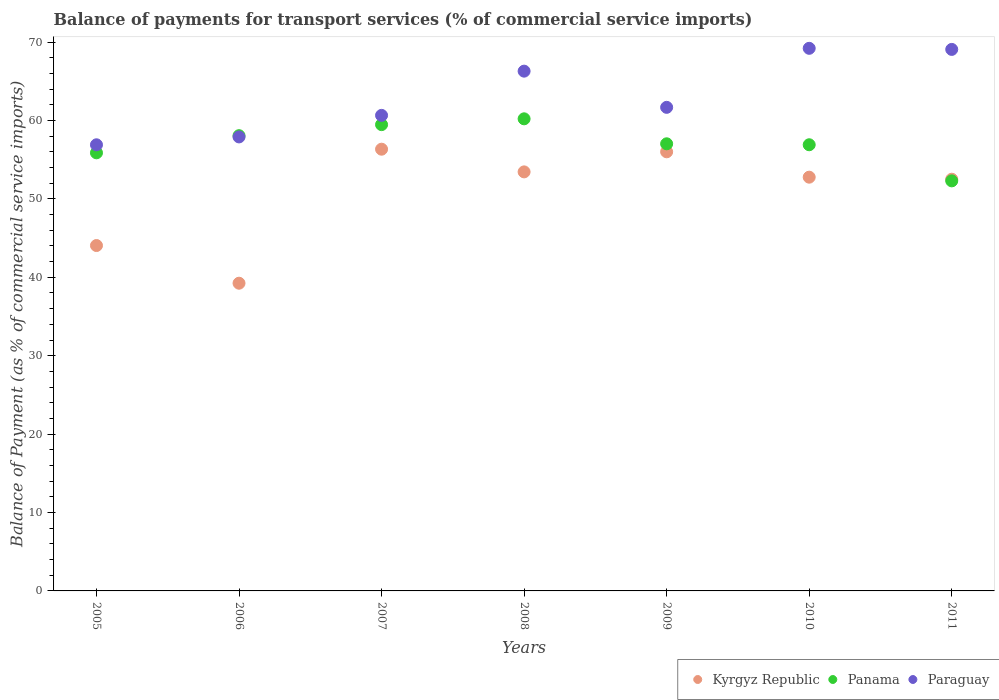Is the number of dotlines equal to the number of legend labels?
Provide a succinct answer. Yes. What is the balance of payments for transport services in Kyrgyz Republic in 2010?
Give a very brief answer. 52.77. Across all years, what is the maximum balance of payments for transport services in Panama?
Provide a succinct answer. 60.21. Across all years, what is the minimum balance of payments for transport services in Kyrgyz Republic?
Offer a very short reply. 39.24. In which year was the balance of payments for transport services in Panama minimum?
Offer a very short reply. 2011. What is the total balance of payments for transport services in Panama in the graph?
Make the answer very short. 399.83. What is the difference between the balance of payments for transport services in Kyrgyz Republic in 2007 and that in 2009?
Keep it short and to the point. 0.33. What is the difference between the balance of payments for transport services in Kyrgyz Republic in 2006 and the balance of payments for transport services in Paraguay in 2007?
Offer a very short reply. -21.4. What is the average balance of payments for transport services in Panama per year?
Provide a short and direct response. 57.12. In the year 2008, what is the difference between the balance of payments for transport services in Panama and balance of payments for transport services in Kyrgyz Republic?
Ensure brevity in your answer.  6.77. What is the ratio of the balance of payments for transport services in Paraguay in 2005 to that in 2008?
Keep it short and to the point. 0.86. Is the balance of payments for transport services in Paraguay in 2009 less than that in 2010?
Ensure brevity in your answer.  Yes. What is the difference between the highest and the second highest balance of payments for transport services in Kyrgyz Republic?
Offer a very short reply. 0.33. What is the difference between the highest and the lowest balance of payments for transport services in Panama?
Provide a succinct answer. 7.91. Does the balance of payments for transport services in Paraguay monotonically increase over the years?
Your answer should be very brief. No. Is the balance of payments for transport services in Kyrgyz Republic strictly greater than the balance of payments for transport services in Paraguay over the years?
Ensure brevity in your answer.  No. What is the difference between two consecutive major ticks on the Y-axis?
Offer a terse response. 10. Does the graph contain grids?
Your response must be concise. No. Where does the legend appear in the graph?
Provide a short and direct response. Bottom right. What is the title of the graph?
Your response must be concise. Balance of payments for transport services (% of commercial service imports). What is the label or title of the X-axis?
Keep it short and to the point. Years. What is the label or title of the Y-axis?
Provide a short and direct response. Balance of Payment (as % of commercial service imports). What is the Balance of Payment (as % of commercial service imports) of Kyrgyz Republic in 2005?
Your response must be concise. 44.05. What is the Balance of Payment (as % of commercial service imports) of Panama in 2005?
Offer a very short reply. 55.87. What is the Balance of Payment (as % of commercial service imports) of Paraguay in 2005?
Provide a succinct answer. 56.9. What is the Balance of Payment (as % of commercial service imports) in Kyrgyz Republic in 2006?
Provide a succinct answer. 39.24. What is the Balance of Payment (as % of commercial service imports) of Panama in 2006?
Offer a terse response. 58.06. What is the Balance of Payment (as % of commercial service imports) in Paraguay in 2006?
Make the answer very short. 57.9. What is the Balance of Payment (as % of commercial service imports) of Kyrgyz Republic in 2007?
Make the answer very short. 56.33. What is the Balance of Payment (as % of commercial service imports) of Panama in 2007?
Make the answer very short. 59.47. What is the Balance of Payment (as % of commercial service imports) of Paraguay in 2007?
Give a very brief answer. 60.65. What is the Balance of Payment (as % of commercial service imports) of Kyrgyz Republic in 2008?
Offer a terse response. 53.44. What is the Balance of Payment (as % of commercial service imports) in Panama in 2008?
Give a very brief answer. 60.21. What is the Balance of Payment (as % of commercial service imports) in Paraguay in 2008?
Provide a short and direct response. 66.29. What is the Balance of Payment (as % of commercial service imports) of Kyrgyz Republic in 2009?
Your answer should be very brief. 56. What is the Balance of Payment (as % of commercial service imports) of Panama in 2009?
Give a very brief answer. 57.02. What is the Balance of Payment (as % of commercial service imports) of Paraguay in 2009?
Offer a terse response. 61.67. What is the Balance of Payment (as % of commercial service imports) of Kyrgyz Republic in 2010?
Provide a succinct answer. 52.77. What is the Balance of Payment (as % of commercial service imports) of Panama in 2010?
Provide a succinct answer. 56.9. What is the Balance of Payment (as % of commercial service imports) in Paraguay in 2010?
Your answer should be compact. 69.2. What is the Balance of Payment (as % of commercial service imports) in Kyrgyz Republic in 2011?
Give a very brief answer. 52.51. What is the Balance of Payment (as % of commercial service imports) of Panama in 2011?
Provide a succinct answer. 52.3. What is the Balance of Payment (as % of commercial service imports) of Paraguay in 2011?
Provide a short and direct response. 69.06. Across all years, what is the maximum Balance of Payment (as % of commercial service imports) in Kyrgyz Republic?
Make the answer very short. 56.33. Across all years, what is the maximum Balance of Payment (as % of commercial service imports) in Panama?
Provide a succinct answer. 60.21. Across all years, what is the maximum Balance of Payment (as % of commercial service imports) in Paraguay?
Give a very brief answer. 69.2. Across all years, what is the minimum Balance of Payment (as % of commercial service imports) in Kyrgyz Republic?
Your answer should be compact. 39.24. Across all years, what is the minimum Balance of Payment (as % of commercial service imports) of Panama?
Provide a short and direct response. 52.3. Across all years, what is the minimum Balance of Payment (as % of commercial service imports) in Paraguay?
Ensure brevity in your answer.  56.9. What is the total Balance of Payment (as % of commercial service imports) of Kyrgyz Republic in the graph?
Ensure brevity in your answer.  354.34. What is the total Balance of Payment (as % of commercial service imports) of Panama in the graph?
Make the answer very short. 399.83. What is the total Balance of Payment (as % of commercial service imports) of Paraguay in the graph?
Offer a terse response. 441.67. What is the difference between the Balance of Payment (as % of commercial service imports) of Kyrgyz Republic in 2005 and that in 2006?
Offer a very short reply. 4.81. What is the difference between the Balance of Payment (as % of commercial service imports) in Panama in 2005 and that in 2006?
Give a very brief answer. -2.19. What is the difference between the Balance of Payment (as % of commercial service imports) of Paraguay in 2005 and that in 2006?
Your answer should be very brief. -1. What is the difference between the Balance of Payment (as % of commercial service imports) of Kyrgyz Republic in 2005 and that in 2007?
Give a very brief answer. -12.29. What is the difference between the Balance of Payment (as % of commercial service imports) of Panama in 2005 and that in 2007?
Ensure brevity in your answer.  -3.59. What is the difference between the Balance of Payment (as % of commercial service imports) of Paraguay in 2005 and that in 2007?
Provide a succinct answer. -3.75. What is the difference between the Balance of Payment (as % of commercial service imports) in Kyrgyz Republic in 2005 and that in 2008?
Provide a short and direct response. -9.39. What is the difference between the Balance of Payment (as % of commercial service imports) in Panama in 2005 and that in 2008?
Give a very brief answer. -4.34. What is the difference between the Balance of Payment (as % of commercial service imports) in Paraguay in 2005 and that in 2008?
Your answer should be very brief. -9.39. What is the difference between the Balance of Payment (as % of commercial service imports) in Kyrgyz Republic in 2005 and that in 2009?
Offer a terse response. -11.95. What is the difference between the Balance of Payment (as % of commercial service imports) in Panama in 2005 and that in 2009?
Keep it short and to the point. -1.15. What is the difference between the Balance of Payment (as % of commercial service imports) in Paraguay in 2005 and that in 2009?
Give a very brief answer. -4.78. What is the difference between the Balance of Payment (as % of commercial service imports) in Kyrgyz Republic in 2005 and that in 2010?
Your answer should be very brief. -8.72. What is the difference between the Balance of Payment (as % of commercial service imports) of Panama in 2005 and that in 2010?
Offer a very short reply. -1.03. What is the difference between the Balance of Payment (as % of commercial service imports) in Paraguay in 2005 and that in 2010?
Make the answer very short. -12.3. What is the difference between the Balance of Payment (as % of commercial service imports) in Kyrgyz Republic in 2005 and that in 2011?
Offer a terse response. -8.46. What is the difference between the Balance of Payment (as % of commercial service imports) in Panama in 2005 and that in 2011?
Make the answer very short. 3.58. What is the difference between the Balance of Payment (as % of commercial service imports) of Paraguay in 2005 and that in 2011?
Your answer should be very brief. -12.16. What is the difference between the Balance of Payment (as % of commercial service imports) in Kyrgyz Republic in 2006 and that in 2007?
Make the answer very short. -17.09. What is the difference between the Balance of Payment (as % of commercial service imports) in Panama in 2006 and that in 2007?
Your answer should be very brief. -1.41. What is the difference between the Balance of Payment (as % of commercial service imports) of Paraguay in 2006 and that in 2007?
Give a very brief answer. -2.75. What is the difference between the Balance of Payment (as % of commercial service imports) in Kyrgyz Republic in 2006 and that in 2008?
Your answer should be very brief. -14.2. What is the difference between the Balance of Payment (as % of commercial service imports) of Panama in 2006 and that in 2008?
Your answer should be very brief. -2.15. What is the difference between the Balance of Payment (as % of commercial service imports) of Paraguay in 2006 and that in 2008?
Keep it short and to the point. -8.39. What is the difference between the Balance of Payment (as % of commercial service imports) in Kyrgyz Republic in 2006 and that in 2009?
Your response must be concise. -16.76. What is the difference between the Balance of Payment (as % of commercial service imports) in Panama in 2006 and that in 2009?
Provide a short and direct response. 1.04. What is the difference between the Balance of Payment (as % of commercial service imports) of Paraguay in 2006 and that in 2009?
Provide a short and direct response. -3.77. What is the difference between the Balance of Payment (as % of commercial service imports) of Kyrgyz Republic in 2006 and that in 2010?
Ensure brevity in your answer.  -13.52. What is the difference between the Balance of Payment (as % of commercial service imports) of Panama in 2006 and that in 2010?
Provide a short and direct response. 1.16. What is the difference between the Balance of Payment (as % of commercial service imports) of Paraguay in 2006 and that in 2010?
Provide a succinct answer. -11.3. What is the difference between the Balance of Payment (as % of commercial service imports) in Kyrgyz Republic in 2006 and that in 2011?
Your response must be concise. -13.26. What is the difference between the Balance of Payment (as % of commercial service imports) in Panama in 2006 and that in 2011?
Offer a very short reply. 5.76. What is the difference between the Balance of Payment (as % of commercial service imports) in Paraguay in 2006 and that in 2011?
Ensure brevity in your answer.  -11.16. What is the difference between the Balance of Payment (as % of commercial service imports) of Kyrgyz Republic in 2007 and that in 2008?
Offer a terse response. 2.89. What is the difference between the Balance of Payment (as % of commercial service imports) of Panama in 2007 and that in 2008?
Provide a succinct answer. -0.74. What is the difference between the Balance of Payment (as % of commercial service imports) of Paraguay in 2007 and that in 2008?
Offer a terse response. -5.64. What is the difference between the Balance of Payment (as % of commercial service imports) in Kyrgyz Republic in 2007 and that in 2009?
Give a very brief answer. 0.33. What is the difference between the Balance of Payment (as % of commercial service imports) of Panama in 2007 and that in 2009?
Give a very brief answer. 2.44. What is the difference between the Balance of Payment (as % of commercial service imports) of Paraguay in 2007 and that in 2009?
Your answer should be very brief. -1.02. What is the difference between the Balance of Payment (as % of commercial service imports) of Kyrgyz Republic in 2007 and that in 2010?
Make the answer very short. 3.57. What is the difference between the Balance of Payment (as % of commercial service imports) in Panama in 2007 and that in 2010?
Provide a short and direct response. 2.57. What is the difference between the Balance of Payment (as % of commercial service imports) in Paraguay in 2007 and that in 2010?
Offer a very short reply. -8.55. What is the difference between the Balance of Payment (as % of commercial service imports) in Kyrgyz Republic in 2007 and that in 2011?
Offer a very short reply. 3.83. What is the difference between the Balance of Payment (as % of commercial service imports) of Panama in 2007 and that in 2011?
Your answer should be compact. 7.17. What is the difference between the Balance of Payment (as % of commercial service imports) of Paraguay in 2007 and that in 2011?
Make the answer very short. -8.41. What is the difference between the Balance of Payment (as % of commercial service imports) in Kyrgyz Republic in 2008 and that in 2009?
Ensure brevity in your answer.  -2.56. What is the difference between the Balance of Payment (as % of commercial service imports) of Panama in 2008 and that in 2009?
Your answer should be very brief. 3.19. What is the difference between the Balance of Payment (as % of commercial service imports) of Paraguay in 2008 and that in 2009?
Your response must be concise. 4.62. What is the difference between the Balance of Payment (as % of commercial service imports) of Kyrgyz Republic in 2008 and that in 2010?
Give a very brief answer. 0.68. What is the difference between the Balance of Payment (as % of commercial service imports) of Panama in 2008 and that in 2010?
Your answer should be compact. 3.31. What is the difference between the Balance of Payment (as % of commercial service imports) in Paraguay in 2008 and that in 2010?
Provide a succinct answer. -2.91. What is the difference between the Balance of Payment (as % of commercial service imports) of Kyrgyz Republic in 2008 and that in 2011?
Keep it short and to the point. 0.94. What is the difference between the Balance of Payment (as % of commercial service imports) of Panama in 2008 and that in 2011?
Ensure brevity in your answer.  7.91. What is the difference between the Balance of Payment (as % of commercial service imports) of Paraguay in 2008 and that in 2011?
Your response must be concise. -2.77. What is the difference between the Balance of Payment (as % of commercial service imports) in Kyrgyz Republic in 2009 and that in 2010?
Your answer should be compact. 3.24. What is the difference between the Balance of Payment (as % of commercial service imports) in Panama in 2009 and that in 2010?
Your response must be concise. 0.12. What is the difference between the Balance of Payment (as % of commercial service imports) in Paraguay in 2009 and that in 2010?
Make the answer very short. -7.53. What is the difference between the Balance of Payment (as % of commercial service imports) of Kyrgyz Republic in 2009 and that in 2011?
Provide a short and direct response. 3.5. What is the difference between the Balance of Payment (as % of commercial service imports) of Panama in 2009 and that in 2011?
Give a very brief answer. 4.73. What is the difference between the Balance of Payment (as % of commercial service imports) in Paraguay in 2009 and that in 2011?
Provide a succinct answer. -7.39. What is the difference between the Balance of Payment (as % of commercial service imports) of Kyrgyz Republic in 2010 and that in 2011?
Offer a very short reply. 0.26. What is the difference between the Balance of Payment (as % of commercial service imports) of Panama in 2010 and that in 2011?
Offer a terse response. 4.61. What is the difference between the Balance of Payment (as % of commercial service imports) of Paraguay in 2010 and that in 2011?
Ensure brevity in your answer.  0.14. What is the difference between the Balance of Payment (as % of commercial service imports) of Kyrgyz Republic in 2005 and the Balance of Payment (as % of commercial service imports) of Panama in 2006?
Your answer should be very brief. -14.01. What is the difference between the Balance of Payment (as % of commercial service imports) in Kyrgyz Republic in 2005 and the Balance of Payment (as % of commercial service imports) in Paraguay in 2006?
Ensure brevity in your answer.  -13.85. What is the difference between the Balance of Payment (as % of commercial service imports) in Panama in 2005 and the Balance of Payment (as % of commercial service imports) in Paraguay in 2006?
Provide a succinct answer. -2.03. What is the difference between the Balance of Payment (as % of commercial service imports) in Kyrgyz Republic in 2005 and the Balance of Payment (as % of commercial service imports) in Panama in 2007?
Provide a succinct answer. -15.42. What is the difference between the Balance of Payment (as % of commercial service imports) in Kyrgyz Republic in 2005 and the Balance of Payment (as % of commercial service imports) in Paraguay in 2007?
Keep it short and to the point. -16.6. What is the difference between the Balance of Payment (as % of commercial service imports) of Panama in 2005 and the Balance of Payment (as % of commercial service imports) of Paraguay in 2007?
Ensure brevity in your answer.  -4.78. What is the difference between the Balance of Payment (as % of commercial service imports) in Kyrgyz Republic in 2005 and the Balance of Payment (as % of commercial service imports) in Panama in 2008?
Give a very brief answer. -16.16. What is the difference between the Balance of Payment (as % of commercial service imports) of Kyrgyz Republic in 2005 and the Balance of Payment (as % of commercial service imports) of Paraguay in 2008?
Your answer should be compact. -22.24. What is the difference between the Balance of Payment (as % of commercial service imports) of Panama in 2005 and the Balance of Payment (as % of commercial service imports) of Paraguay in 2008?
Offer a very short reply. -10.42. What is the difference between the Balance of Payment (as % of commercial service imports) of Kyrgyz Republic in 2005 and the Balance of Payment (as % of commercial service imports) of Panama in 2009?
Keep it short and to the point. -12.97. What is the difference between the Balance of Payment (as % of commercial service imports) in Kyrgyz Republic in 2005 and the Balance of Payment (as % of commercial service imports) in Paraguay in 2009?
Offer a very short reply. -17.62. What is the difference between the Balance of Payment (as % of commercial service imports) of Panama in 2005 and the Balance of Payment (as % of commercial service imports) of Paraguay in 2009?
Provide a short and direct response. -5.8. What is the difference between the Balance of Payment (as % of commercial service imports) of Kyrgyz Republic in 2005 and the Balance of Payment (as % of commercial service imports) of Panama in 2010?
Give a very brief answer. -12.85. What is the difference between the Balance of Payment (as % of commercial service imports) in Kyrgyz Republic in 2005 and the Balance of Payment (as % of commercial service imports) in Paraguay in 2010?
Offer a terse response. -25.15. What is the difference between the Balance of Payment (as % of commercial service imports) of Panama in 2005 and the Balance of Payment (as % of commercial service imports) of Paraguay in 2010?
Offer a terse response. -13.33. What is the difference between the Balance of Payment (as % of commercial service imports) in Kyrgyz Republic in 2005 and the Balance of Payment (as % of commercial service imports) in Panama in 2011?
Your response must be concise. -8.25. What is the difference between the Balance of Payment (as % of commercial service imports) of Kyrgyz Republic in 2005 and the Balance of Payment (as % of commercial service imports) of Paraguay in 2011?
Ensure brevity in your answer.  -25.01. What is the difference between the Balance of Payment (as % of commercial service imports) in Panama in 2005 and the Balance of Payment (as % of commercial service imports) in Paraguay in 2011?
Ensure brevity in your answer.  -13.19. What is the difference between the Balance of Payment (as % of commercial service imports) in Kyrgyz Republic in 2006 and the Balance of Payment (as % of commercial service imports) in Panama in 2007?
Provide a short and direct response. -20.22. What is the difference between the Balance of Payment (as % of commercial service imports) in Kyrgyz Republic in 2006 and the Balance of Payment (as % of commercial service imports) in Paraguay in 2007?
Offer a very short reply. -21.4. What is the difference between the Balance of Payment (as % of commercial service imports) in Panama in 2006 and the Balance of Payment (as % of commercial service imports) in Paraguay in 2007?
Keep it short and to the point. -2.59. What is the difference between the Balance of Payment (as % of commercial service imports) of Kyrgyz Republic in 2006 and the Balance of Payment (as % of commercial service imports) of Panama in 2008?
Your response must be concise. -20.97. What is the difference between the Balance of Payment (as % of commercial service imports) in Kyrgyz Republic in 2006 and the Balance of Payment (as % of commercial service imports) in Paraguay in 2008?
Provide a succinct answer. -27.05. What is the difference between the Balance of Payment (as % of commercial service imports) in Panama in 2006 and the Balance of Payment (as % of commercial service imports) in Paraguay in 2008?
Keep it short and to the point. -8.23. What is the difference between the Balance of Payment (as % of commercial service imports) of Kyrgyz Republic in 2006 and the Balance of Payment (as % of commercial service imports) of Panama in 2009?
Give a very brief answer. -17.78. What is the difference between the Balance of Payment (as % of commercial service imports) of Kyrgyz Republic in 2006 and the Balance of Payment (as % of commercial service imports) of Paraguay in 2009?
Keep it short and to the point. -22.43. What is the difference between the Balance of Payment (as % of commercial service imports) of Panama in 2006 and the Balance of Payment (as % of commercial service imports) of Paraguay in 2009?
Offer a terse response. -3.61. What is the difference between the Balance of Payment (as % of commercial service imports) in Kyrgyz Republic in 2006 and the Balance of Payment (as % of commercial service imports) in Panama in 2010?
Provide a short and direct response. -17.66. What is the difference between the Balance of Payment (as % of commercial service imports) of Kyrgyz Republic in 2006 and the Balance of Payment (as % of commercial service imports) of Paraguay in 2010?
Your response must be concise. -29.96. What is the difference between the Balance of Payment (as % of commercial service imports) of Panama in 2006 and the Balance of Payment (as % of commercial service imports) of Paraguay in 2010?
Provide a short and direct response. -11.14. What is the difference between the Balance of Payment (as % of commercial service imports) in Kyrgyz Republic in 2006 and the Balance of Payment (as % of commercial service imports) in Panama in 2011?
Offer a terse response. -13.05. What is the difference between the Balance of Payment (as % of commercial service imports) of Kyrgyz Republic in 2006 and the Balance of Payment (as % of commercial service imports) of Paraguay in 2011?
Provide a succinct answer. -29.82. What is the difference between the Balance of Payment (as % of commercial service imports) in Panama in 2006 and the Balance of Payment (as % of commercial service imports) in Paraguay in 2011?
Offer a terse response. -11. What is the difference between the Balance of Payment (as % of commercial service imports) of Kyrgyz Republic in 2007 and the Balance of Payment (as % of commercial service imports) of Panama in 2008?
Your answer should be very brief. -3.87. What is the difference between the Balance of Payment (as % of commercial service imports) of Kyrgyz Republic in 2007 and the Balance of Payment (as % of commercial service imports) of Paraguay in 2008?
Provide a succinct answer. -9.95. What is the difference between the Balance of Payment (as % of commercial service imports) in Panama in 2007 and the Balance of Payment (as % of commercial service imports) in Paraguay in 2008?
Provide a short and direct response. -6.82. What is the difference between the Balance of Payment (as % of commercial service imports) in Kyrgyz Republic in 2007 and the Balance of Payment (as % of commercial service imports) in Panama in 2009?
Offer a terse response. -0.69. What is the difference between the Balance of Payment (as % of commercial service imports) in Kyrgyz Republic in 2007 and the Balance of Payment (as % of commercial service imports) in Paraguay in 2009?
Your answer should be compact. -5.34. What is the difference between the Balance of Payment (as % of commercial service imports) in Panama in 2007 and the Balance of Payment (as % of commercial service imports) in Paraguay in 2009?
Provide a short and direct response. -2.21. What is the difference between the Balance of Payment (as % of commercial service imports) of Kyrgyz Republic in 2007 and the Balance of Payment (as % of commercial service imports) of Panama in 2010?
Make the answer very short. -0.57. What is the difference between the Balance of Payment (as % of commercial service imports) of Kyrgyz Republic in 2007 and the Balance of Payment (as % of commercial service imports) of Paraguay in 2010?
Offer a very short reply. -12.87. What is the difference between the Balance of Payment (as % of commercial service imports) of Panama in 2007 and the Balance of Payment (as % of commercial service imports) of Paraguay in 2010?
Keep it short and to the point. -9.73. What is the difference between the Balance of Payment (as % of commercial service imports) of Kyrgyz Republic in 2007 and the Balance of Payment (as % of commercial service imports) of Panama in 2011?
Your answer should be compact. 4.04. What is the difference between the Balance of Payment (as % of commercial service imports) in Kyrgyz Republic in 2007 and the Balance of Payment (as % of commercial service imports) in Paraguay in 2011?
Provide a succinct answer. -12.73. What is the difference between the Balance of Payment (as % of commercial service imports) of Panama in 2007 and the Balance of Payment (as % of commercial service imports) of Paraguay in 2011?
Your answer should be very brief. -9.59. What is the difference between the Balance of Payment (as % of commercial service imports) in Kyrgyz Republic in 2008 and the Balance of Payment (as % of commercial service imports) in Panama in 2009?
Offer a very short reply. -3.58. What is the difference between the Balance of Payment (as % of commercial service imports) in Kyrgyz Republic in 2008 and the Balance of Payment (as % of commercial service imports) in Paraguay in 2009?
Your response must be concise. -8.23. What is the difference between the Balance of Payment (as % of commercial service imports) of Panama in 2008 and the Balance of Payment (as % of commercial service imports) of Paraguay in 2009?
Provide a short and direct response. -1.46. What is the difference between the Balance of Payment (as % of commercial service imports) of Kyrgyz Republic in 2008 and the Balance of Payment (as % of commercial service imports) of Panama in 2010?
Make the answer very short. -3.46. What is the difference between the Balance of Payment (as % of commercial service imports) in Kyrgyz Republic in 2008 and the Balance of Payment (as % of commercial service imports) in Paraguay in 2010?
Your answer should be very brief. -15.76. What is the difference between the Balance of Payment (as % of commercial service imports) of Panama in 2008 and the Balance of Payment (as % of commercial service imports) of Paraguay in 2010?
Your response must be concise. -8.99. What is the difference between the Balance of Payment (as % of commercial service imports) of Kyrgyz Republic in 2008 and the Balance of Payment (as % of commercial service imports) of Panama in 2011?
Keep it short and to the point. 1.15. What is the difference between the Balance of Payment (as % of commercial service imports) in Kyrgyz Republic in 2008 and the Balance of Payment (as % of commercial service imports) in Paraguay in 2011?
Make the answer very short. -15.62. What is the difference between the Balance of Payment (as % of commercial service imports) in Panama in 2008 and the Balance of Payment (as % of commercial service imports) in Paraguay in 2011?
Your answer should be very brief. -8.85. What is the difference between the Balance of Payment (as % of commercial service imports) in Kyrgyz Republic in 2009 and the Balance of Payment (as % of commercial service imports) in Panama in 2010?
Your answer should be very brief. -0.9. What is the difference between the Balance of Payment (as % of commercial service imports) of Kyrgyz Republic in 2009 and the Balance of Payment (as % of commercial service imports) of Paraguay in 2010?
Offer a very short reply. -13.2. What is the difference between the Balance of Payment (as % of commercial service imports) of Panama in 2009 and the Balance of Payment (as % of commercial service imports) of Paraguay in 2010?
Your answer should be compact. -12.18. What is the difference between the Balance of Payment (as % of commercial service imports) in Kyrgyz Republic in 2009 and the Balance of Payment (as % of commercial service imports) in Panama in 2011?
Give a very brief answer. 3.71. What is the difference between the Balance of Payment (as % of commercial service imports) of Kyrgyz Republic in 2009 and the Balance of Payment (as % of commercial service imports) of Paraguay in 2011?
Offer a very short reply. -13.06. What is the difference between the Balance of Payment (as % of commercial service imports) of Panama in 2009 and the Balance of Payment (as % of commercial service imports) of Paraguay in 2011?
Your answer should be very brief. -12.04. What is the difference between the Balance of Payment (as % of commercial service imports) of Kyrgyz Republic in 2010 and the Balance of Payment (as % of commercial service imports) of Panama in 2011?
Offer a very short reply. 0.47. What is the difference between the Balance of Payment (as % of commercial service imports) of Kyrgyz Republic in 2010 and the Balance of Payment (as % of commercial service imports) of Paraguay in 2011?
Give a very brief answer. -16.29. What is the difference between the Balance of Payment (as % of commercial service imports) in Panama in 2010 and the Balance of Payment (as % of commercial service imports) in Paraguay in 2011?
Offer a very short reply. -12.16. What is the average Balance of Payment (as % of commercial service imports) of Kyrgyz Republic per year?
Give a very brief answer. 50.62. What is the average Balance of Payment (as % of commercial service imports) of Panama per year?
Offer a very short reply. 57.12. What is the average Balance of Payment (as % of commercial service imports) in Paraguay per year?
Provide a short and direct response. 63.1. In the year 2005, what is the difference between the Balance of Payment (as % of commercial service imports) in Kyrgyz Republic and Balance of Payment (as % of commercial service imports) in Panama?
Ensure brevity in your answer.  -11.82. In the year 2005, what is the difference between the Balance of Payment (as % of commercial service imports) of Kyrgyz Republic and Balance of Payment (as % of commercial service imports) of Paraguay?
Your answer should be very brief. -12.85. In the year 2005, what is the difference between the Balance of Payment (as % of commercial service imports) in Panama and Balance of Payment (as % of commercial service imports) in Paraguay?
Offer a terse response. -1.02. In the year 2006, what is the difference between the Balance of Payment (as % of commercial service imports) in Kyrgyz Republic and Balance of Payment (as % of commercial service imports) in Panama?
Keep it short and to the point. -18.82. In the year 2006, what is the difference between the Balance of Payment (as % of commercial service imports) in Kyrgyz Republic and Balance of Payment (as % of commercial service imports) in Paraguay?
Give a very brief answer. -18.66. In the year 2006, what is the difference between the Balance of Payment (as % of commercial service imports) in Panama and Balance of Payment (as % of commercial service imports) in Paraguay?
Keep it short and to the point. 0.16. In the year 2007, what is the difference between the Balance of Payment (as % of commercial service imports) of Kyrgyz Republic and Balance of Payment (as % of commercial service imports) of Panama?
Your response must be concise. -3.13. In the year 2007, what is the difference between the Balance of Payment (as % of commercial service imports) of Kyrgyz Republic and Balance of Payment (as % of commercial service imports) of Paraguay?
Give a very brief answer. -4.31. In the year 2007, what is the difference between the Balance of Payment (as % of commercial service imports) in Panama and Balance of Payment (as % of commercial service imports) in Paraguay?
Keep it short and to the point. -1.18. In the year 2008, what is the difference between the Balance of Payment (as % of commercial service imports) of Kyrgyz Republic and Balance of Payment (as % of commercial service imports) of Panama?
Give a very brief answer. -6.77. In the year 2008, what is the difference between the Balance of Payment (as % of commercial service imports) in Kyrgyz Republic and Balance of Payment (as % of commercial service imports) in Paraguay?
Offer a terse response. -12.85. In the year 2008, what is the difference between the Balance of Payment (as % of commercial service imports) in Panama and Balance of Payment (as % of commercial service imports) in Paraguay?
Your answer should be compact. -6.08. In the year 2009, what is the difference between the Balance of Payment (as % of commercial service imports) of Kyrgyz Republic and Balance of Payment (as % of commercial service imports) of Panama?
Give a very brief answer. -1.02. In the year 2009, what is the difference between the Balance of Payment (as % of commercial service imports) of Kyrgyz Republic and Balance of Payment (as % of commercial service imports) of Paraguay?
Your response must be concise. -5.67. In the year 2009, what is the difference between the Balance of Payment (as % of commercial service imports) in Panama and Balance of Payment (as % of commercial service imports) in Paraguay?
Give a very brief answer. -4.65. In the year 2010, what is the difference between the Balance of Payment (as % of commercial service imports) of Kyrgyz Republic and Balance of Payment (as % of commercial service imports) of Panama?
Offer a terse response. -4.14. In the year 2010, what is the difference between the Balance of Payment (as % of commercial service imports) in Kyrgyz Republic and Balance of Payment (as % of commercial service imports) in Paraguay?
Ensure brevity in your answer.  -16.43. In the year 2010, what is the difference between the Balance of Payment (as % of commercial service imports) of Panama and Balance of Payment (as % of commercial service imports) of Paraguay?
Make the answer very short. -12.3. In the year 2011, what is the difference between the Balance of Payment (as % of commercial service imports) of Kyrgyz Republic and Balance of Payment (as % of commercial service imports) of Panama?
Provide a short and direct response. 0.21. In the year 2011, what is the difference between the Balance of Payment (as % of commercial service imports) in Kyrgyz Republic and Balance of Payment (as % of commercial service imports) in Paraguay?
Your response must be concise. -16.56. In the year 2011, what is the difference between the Balance of Payment (as % of commercial service imports) in Panama and Balance of Payment (as % of commercial service imports) in Paraguay?
Make the answer very short. -16.77. What is the ratio of the Balance of Payment (as % of commercial service imports) of Kyrgyz Republic in 2005 to that in 2006?
Provide a short and direct response. 1.12. What is the ratio of the Balance of Payment (as % of commercial service imports) in Panama in 2005 to that in 2006?
Provide a succinct answer. 0.96. What is the ratio of the Balance of Payment (as % of commercial service imports) of Paraguay in 2005 to that in 2006?
Provide a short and direct response. 0.98. What is the ratio of the Balance of Payment (as % of commercial service imports) of Kyrgyz Republic in 2005 to that in 2007?
Offer a very short reply. 0.78. What is the ratio of the Balance of Payment (as % of commercial service imports) in Panama in 2005 to that in 2007?
Offer a terse response. 0.94. What is the ratio of the Balance of Payment (as % of commercial service imports) of Paraguay in 2005 to that in 2007?
Keep it short and to the point. 0.94. What is the ratio of the Balance of Payment (as % of commercial service imports) in Kyrgyz Republic in 2005 to that in 2008?
Make the answer very short. 0.82. What is the ratio of the Balance of Payment (as % of commercial service imports) of Panama in 2005 to that in 2008?
Give a very brief answer. 0.93. What is the ratio of the Balance of Payment (as % of commercial service imports) in Paraguay in 2005 to that in 2008?
Your answer should be compact. 0.86. What is the ratio of the Balance of Payment (as % of commercial service imports) of Kyrgyz Republic in 2005 to that in 2009?
Your answer should be compact. 0.79. What is the ratio of the Balance of Payment (as % of commercial service imports) in Panama in 2005 to that in 2009?
Provide a succinct answer. 0.98. What is the ratio of the Balance of Payment (as % of commercial service imports) of Paraguay in 2005 to that in 2009?
Provide a succinct answer. 0.92. What is the ratio of the Balance of Payment (as % of commercial service imports) of Kyrgyz Republic in 2005 to that in 2010?
Offer a very short reply. 0.83. What is the ratio of the Balance of Payment (as % of commercial service imports) in Panama in 2005 to that in 2010?
Keep it short and to the point. 0.98. What is the ratio of the Balance of Payment (as % of commercial service imports) of Paraguay in 2005 to that in 2010?
Provide a succinct answer. 0.82. What is the ratio of the Balance of Payment (as % of commercial service imports) in Kyrgyz Republic in 2005 to that in 2011?
Offer a terse response. 0.84. What is the ratio of the Balance of Payment (as % of commercial service imports) in Panama in 2005 to that in 2011?
Your answer should be compact. 1.07. What is the ratio of the Balance of Payment (as % of commercial service imports) in Paraguay in 2005 to that in 2011?
Your response must be concise. 0.82. What is the ratio of the Balance of Payment (as % of commercial service imports) of Kyrgyz Republic in 2006 to that in 2007?
Make the answer very short. 0.7. What is the ratio of the Balance of Payment (as % of commercial service imports) in Panama in 2006 to that in 2007?
Ensure brevity in your answer.  0.98. What is the ratio of the Balance of Payment (as % of commercial service imports) of Paraguay in 2006 to that in 2007?
Your response must be concise. 0.95. What is the ratio of the Balance of Payment (as % of commercial service imports) of Kyrgyz Republic in 2006 to that in 2008?
Make the answer very short. 0.73. What is the ratio of the Balance of Payment (as % of commercial service imports) of Panama in 2006 to that in 2008?
Ensure brevity in your answer.  0.96. What is the ratio of the Balance of Payment (as % of commercial service imports) in Paraguay in 2006 to that in 2008?
Ensure brevity in your answer.  0.87. What is the ratio of the Balance of Payment (as % of commercial service imports) of Kyrgyz Republic in 2006 to that in 2009?
Provide a succinct answer. 0.7. What is the ratio of the Balance of Payment (as % of commercial service imports) in Panama in 2006 to that in 2009?
Give a very brief answer. 1.02. What is the ratio of the Balance of Payment (as % of commercial service imports) in Paraguay in 2006 to that in 2009?
Give a very brief answer. 0.94. What is the ratio of the Balance of Payment (as % of commercial service imports) in Kyrgyz Republic in 2006 to that in 2010?
Your answer should be compact. 0.74. What is the ratio of the Balance of Payment (as % of commercial service imports) in Panama in 2006 to that in 2010?
Give a very brief answer. 1.02. What is the ratio of the Balance of Payment (as % of commercial service imports) in Paraguay in 2006 to that in 2010?
Make the answer very short. 0.84. What is the ratio of the Balance of Payment (as % of commercial service imports) of Kyrgyz Republic in 2006 to that in 2011?
Your response must be concise. 0.75. What is the ratio of the Balance of Payment (as % of commercial service imports) of Panama in 2006 to that in 2011?
Ensure brevity in your answer.  1.11. What is the ratio of the Balance of Payment (as % of commercial service imports) in Paraguay in 2006 to that in 2011?
Offer a very short reply. 0.84. What is the ratio of the Balance of Payment (as % of commercial service imports) of Kyrgyz Republic in 2007 to that in 2008?
Provide a succinct answer. 1.05. What is the ratio of the Balance of Payment (as % of commercial service imports) of Paraguay in 2007 to that in 2008?
Give a very brief answer. 0.91. What is the ratio of the Balance of Payment (as % of commercial service imports) in Kyrgyz Republic in 2007 to that in 2009?
Ensure brevity in your answer.  1.01. What is the ratio of the Balance of Payment (as % of commercial service imports) in Panama in 2007 to that in 2009?
Provide a succinct answer. 1.04. What is the ratio of the Balance of Payment (as % of commercial service imports) in Paraguay in 2007 to that in 2009?
Your answer should be compact. 0.98. What is the ratio of the Balance of Payment (as % of commercial service imports) of Kyrgyz Republic in 2007 to that in 2010?
Make the answer very short. 1.07. What is the ratio of the Balance of Payment (as % of commercial service imports) in Panama in 2007 to that in 2010?
Your answer should be compact. 1.05. What is the ratio of the Balance of Payment (as % of commercial service imports) in Paraguay in 2007 to that in 2010?
Offer a very short reply. 0.88. What is the ratio of the Balance of Payment (as % of commercial service imports) of Kyrgyz Republic in 2007 to that in 2011?
Offer a terse response. 1.07. What is the ratio of the Balance of Payment (as % of commercial service imports) of Panama in 2007 to that in 2011?
Your answer should be very brief. 1.14. What is the ratio of the Balance of Payment (as % of commercial service imports) in Paraguay in 2007 to that in 2011?
Give a very brief answer. 0.88. What is the ratio of the Balance of Payment (as % of commercial service imports) in Kyrgyz Republic in 2008 to that in 2009?
Your response must be concise. 0.95. What is the ratio of the Balance of Payment (as % of commercial service imports) of Panama in 2008 to that in 2009?
Give a very brief answer. 1.06. What is the ratio of the Balance of Payment (as % of commercial service imports) of Paraguay in 2008 to that in 2009?
Offer a terse response. 1.07. What is the ratio of the Balance of Payment (as % of commercial service imports) of Kyrgyz Republic in 2008 to that in 2010?
Keep it short and to the point. 1.01. What is the ratio of the Balance of Payment (as % of commercial service imports) of Panama in 2008 to that in 2010?
Your answer should be compact. 1.06. What is the ratio of the Balance of Payment (as % of commercial service imports) in Paraguay in 2008 to that in 2010?
Your answer should be very brief. 0.96. What is the ratio of the Balance of Payment (as % of commercial service imports) in Kyrgyz Republic in 2008 to that in 2011?
Offer a terse response. 1.02. What is the ratio of the Balance of Payment (as % of commercial service imports) of Panama in 2008 to that in 2011?
Give a very brief answer. 1.15. What is the ratio of the Balance of Payment (as % of commercial service imports) of Paraguay in 2008 to that in 2011?
Keep it short and to the point. 0.96. What is the ratio of the Balance of Payment (as % of commercial service imports) in Kyrgyz Republic in 2009 to that in 2010?
Provide a succinct answer. 1.06. What is the ratio of the Balance of Payment (as % of commercial service imports) in Paraguay in 2009 to that in 2010?
Ensure brevity in your answer.  0.89. What is the ratio of the Balance of Payment (as % of commercial service imports) in Kyrgyz Republic in 2009 to that in 2011?
Give a very brief answer. 1.07. What is the ratio of the Balance of Payment (as % of commercial service imports) of Panama in 2009 to that in 2011?
Make the answer very short. 1.09. What is the ratio of the Balance of Payment (as % of commercial service imports) of Paraguay in 2009 to that in 2011?
Offer a terse response. 0.89. What is the ratio of the Balance of Payment (as % of commercial service imports) of Panama in 2010 to that in 2011?
Ensure brevity in your answer.  1.09. What is the ratio of the Balance of Payment (as % of commercial service imports) in Paraguay in 2010 to that in 2011?
Make the answer very short. 1. What is the difference between the highest and the second highest Balance of Payment (as % of commercial service imports) in Kyrgyz Republic?
Ensure brevity in your answer.  0.33. What is the difference between the highest and the second highest Balance of Payment (as % of commercial service imports) in Panama?
Provide a short and direct response. 0.74. What is the difference between the highest and the second highest Balance of Payment (as % of commercial service imports) in Paraguay?
Keep it short and to the point. 0.14. What is the difference between the highest and the lowest Balance of Payment (as % of commercial service imports) of Kyrgyz Republic?
Make the answer very short. 17.09. What is the difference between the highest and the lowest Balance of Payment (as % of commercial service imports) of Panama?
Your answer should be very brief. 7.91. What is the difference between the highest and the lowest Balance of Payment (as % of commercial service imports) in Paraguay?
Offer a terse response. 12.3. 